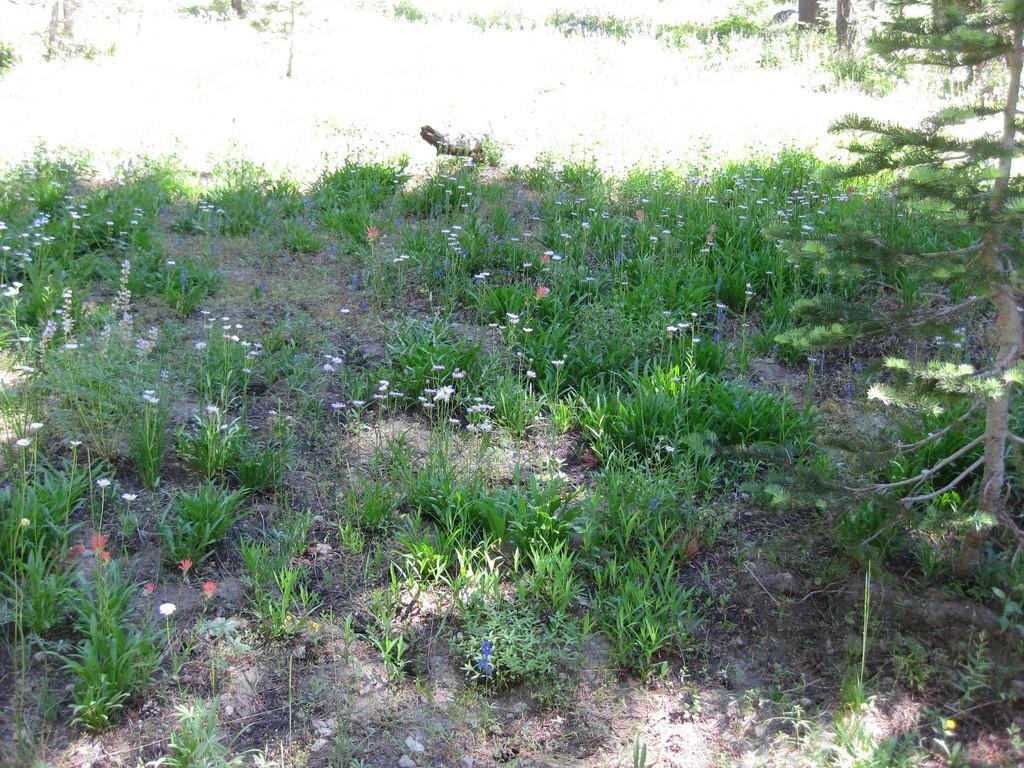Describe this image in one or two sentences. In this image there are plants and flowers and there is a bird which is black in colour. 